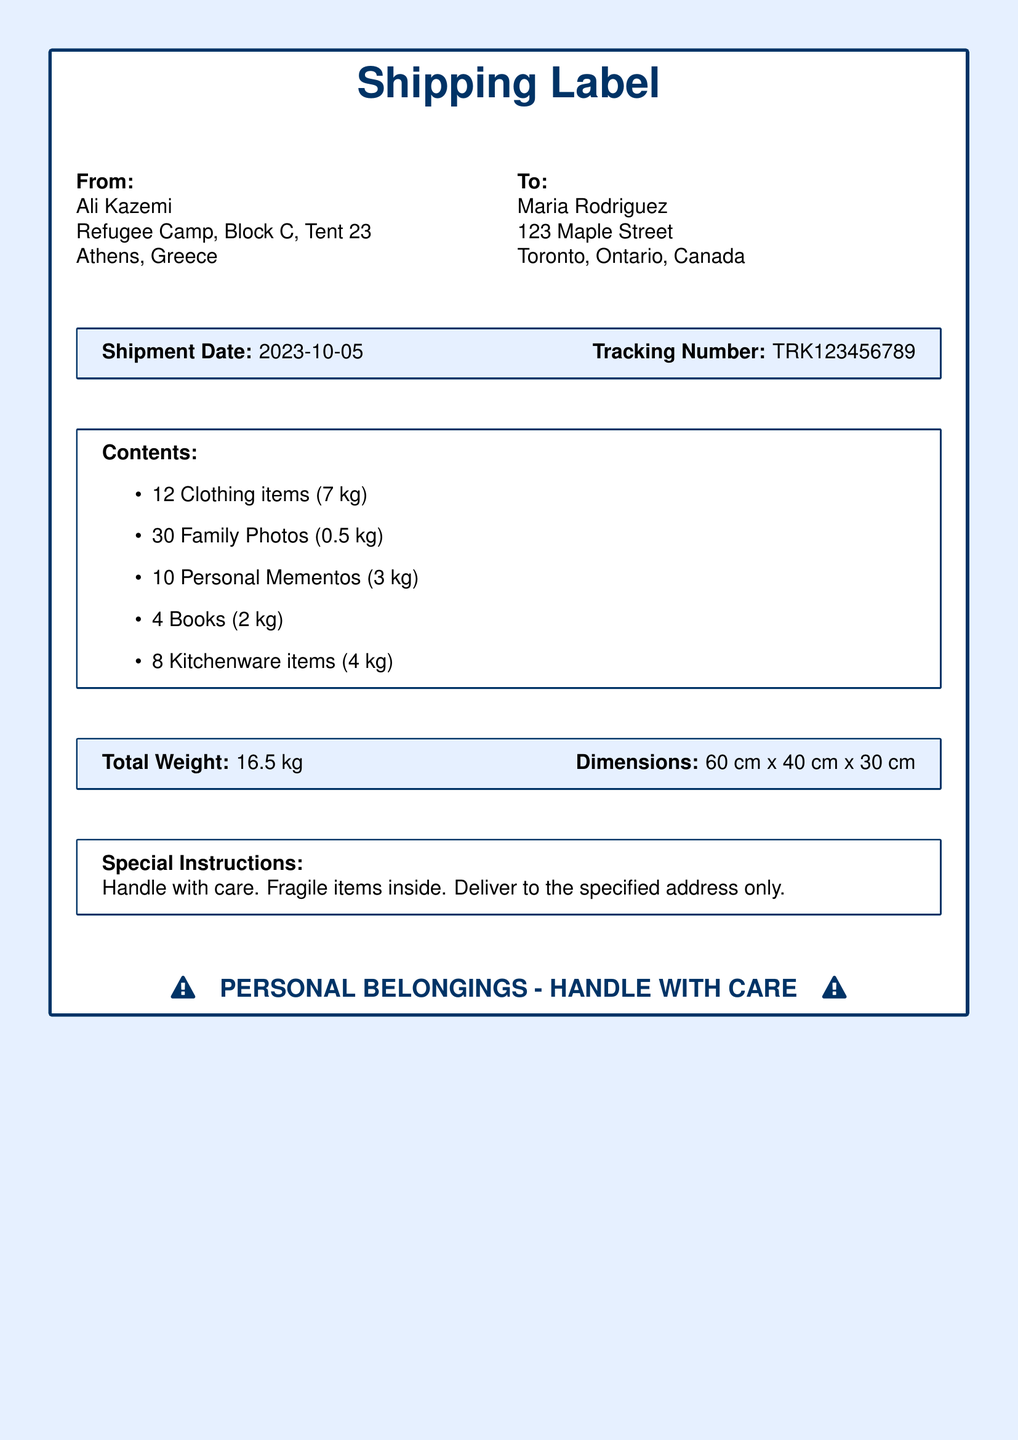What is the name of the sender? The sender's name is listed at the top of the document under "From".
Answer: Ali Kazemi What is the recipient's address? The recipient's address is provided in the "To" section of the document.
Answer: 123 Maple Street, Toronto, Ontario, Canada What is the shipment date? The shipment date is noted in the box with shipment details.
Answer: 2023-10-05 What is the total weight of the shipment? The total weight is mentioned in the last box of the shipment details.
Answer: 16.5 kg How many clothing items are included in the shipment? The number of clothing items is listed under the "Contents" section.
Answer: 12 What is the weight of the personal mementos? The weight of personal mementos is directly provided in the itemized list.
Answer: 3 kg What are the special instructions for this shipment? The special instructions are specified in the corresponding section of the document.
Answer: Handle with care. Fragile items inside What tracking number is associated with this shipment? The tracking number is indicated in the shipment details box.
Answer: TRK123456789 How many family photos are in the shipment? The total number of family photos is included in the "Contents" section.
Answer: 30 